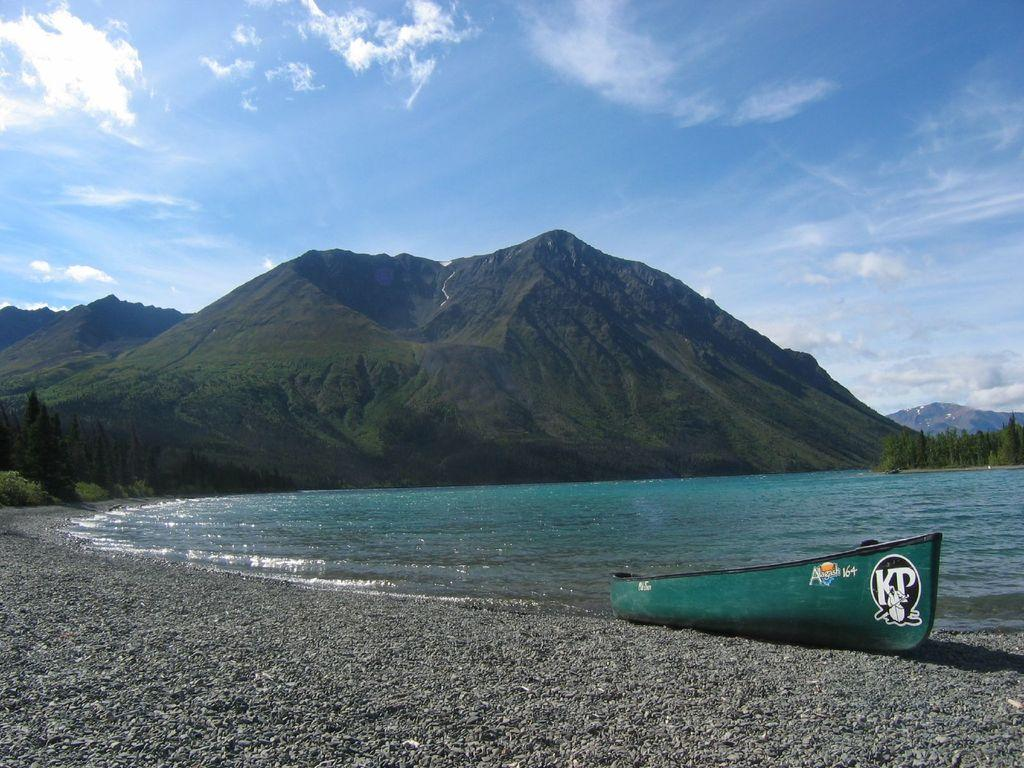What is the main subject of the image? The main subject of the image is a boat. Where is the boat located in the image? The boat is on stones in the image. What can be seen in the background of the image? There are mountains, trees, and water visible in the image. What is visible in the sky in the image? There are clouds in the sky in the image. What type of box can be seen on the boat in the image? There is no box present on the boat in the image. Is there a bridge connecting the boat to the mountains in the image? There is no bridge visible in the image; the boat is on stones near the water. 